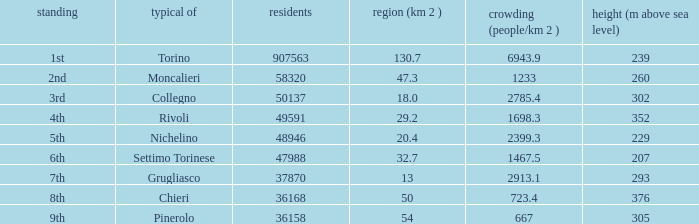The common of Chieri has what population density? 723.4. 